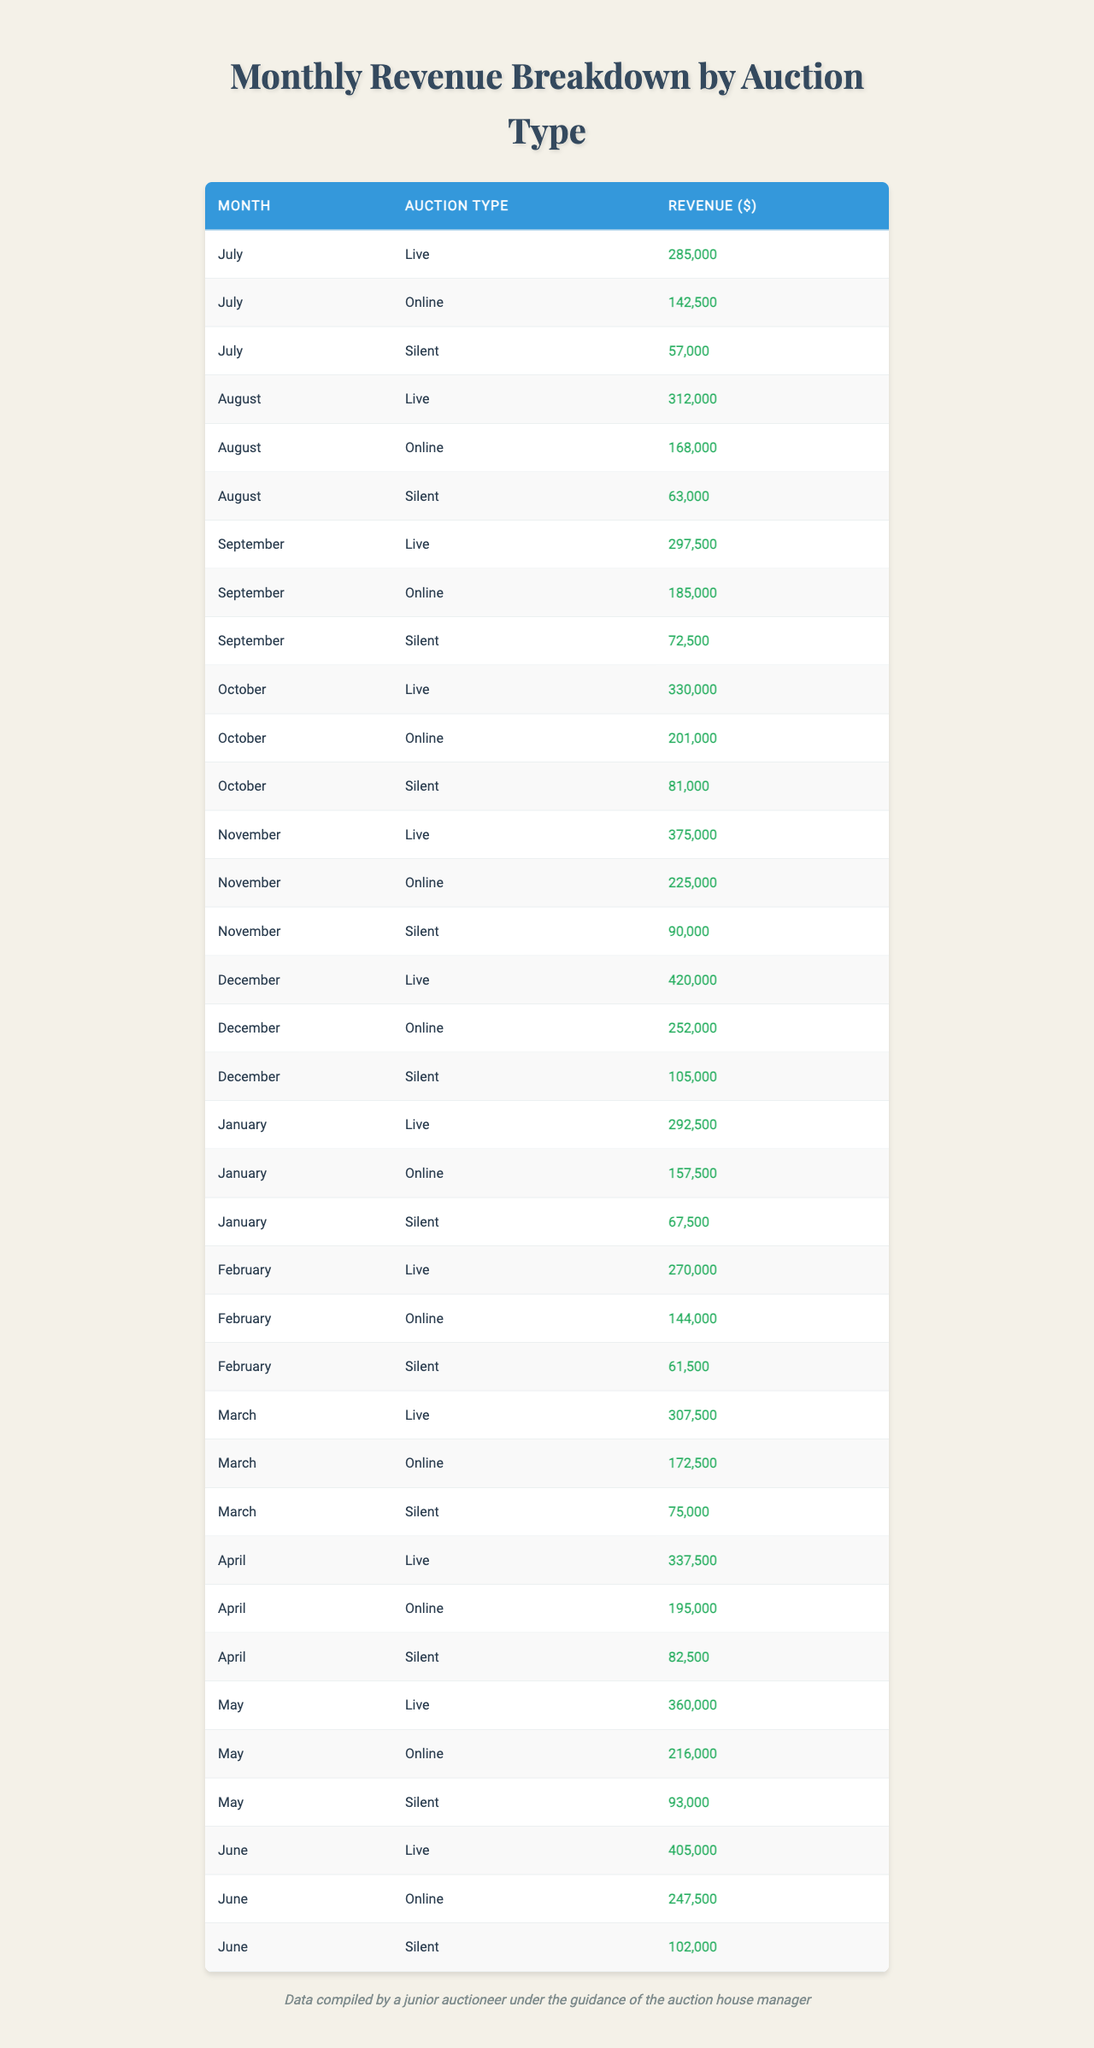What was the total revenue from live auctions in November? From the table, the revenue from live auctions in November is 375,000.
Answer: 375,000 Which auction type generated the highest revenue in December? From the table, we compare the revenues: Live (420,000), Online (252,000), and Silent (105,000). The highest revenue is from Live auctions.
Answer: Live What was the average revenue from online auctions over the fiscal year? To find the average, we add all online auction revenues: (142,500 + 168,000 + 185,000 + 201,000 + 225,000 + 252,000 + 157,500 + 144,000 + 172,500 + 195,000 + 216,000 + 247,500) = 2,057,500, and divide by the number of months (12), giving us 2,057,500 / 12 = 171,458.33.
Answer: 171,458.33 What was the total revenue from silent auctions across all months? We sum up all silent auction revenues: (57,000 + 63,000 + 72,500 + 81,000 + 90,000 + 105,000 + 67,500 + 61,500 + 75,000 + 82,500 + 93,000 + 102,000) = 1,071,000.
Answer: 1,071,000 In which month did online auctions first exceed 200,000 dollars? Checking the online auction revenue month by month: July (142,500), August (168,000), September (185,000), October (201,000). The first month to exceed 200,000 is October.
Answer: October Was the revenue from live auctions higher in June than in May? Earnings for June (405,000) are compared with May's (360,000). June's revenue is greater than May's.
Answer: Yes What is the difference in revenue between live and silent auctions in April? In April, live auctions earned 337,500 and silent auctions earned 82,500. The difference is 337,500 - 82,500 = 255,000.
Answer: 255,000 Which auction type had the lowest revenue in September? Comparing the September revenues: Live (297,500), Online (185,000), Silent (72,500), Silent has the lowest revenue.
Answer: Silent How much more revenue did live auctions generate than online auctions in January? For January, revenue from live auctions is 292,500 and from online is 157,500. The difference is 292,500 - 157,500 = 135,000.
Answer: 135,000 What is the total revenue generated from silent auctions in the first half of the fiscal year? Adding up silent auctions from July to December: (57,000 + 63,000 + 72,500 + 81,000 + 90,000 + 105,000) = 468,500.
Answer: 468,500 